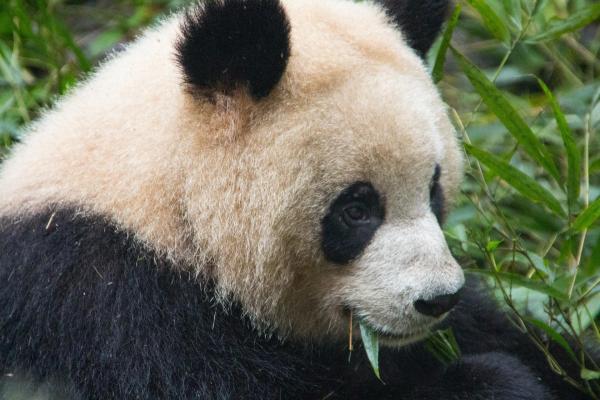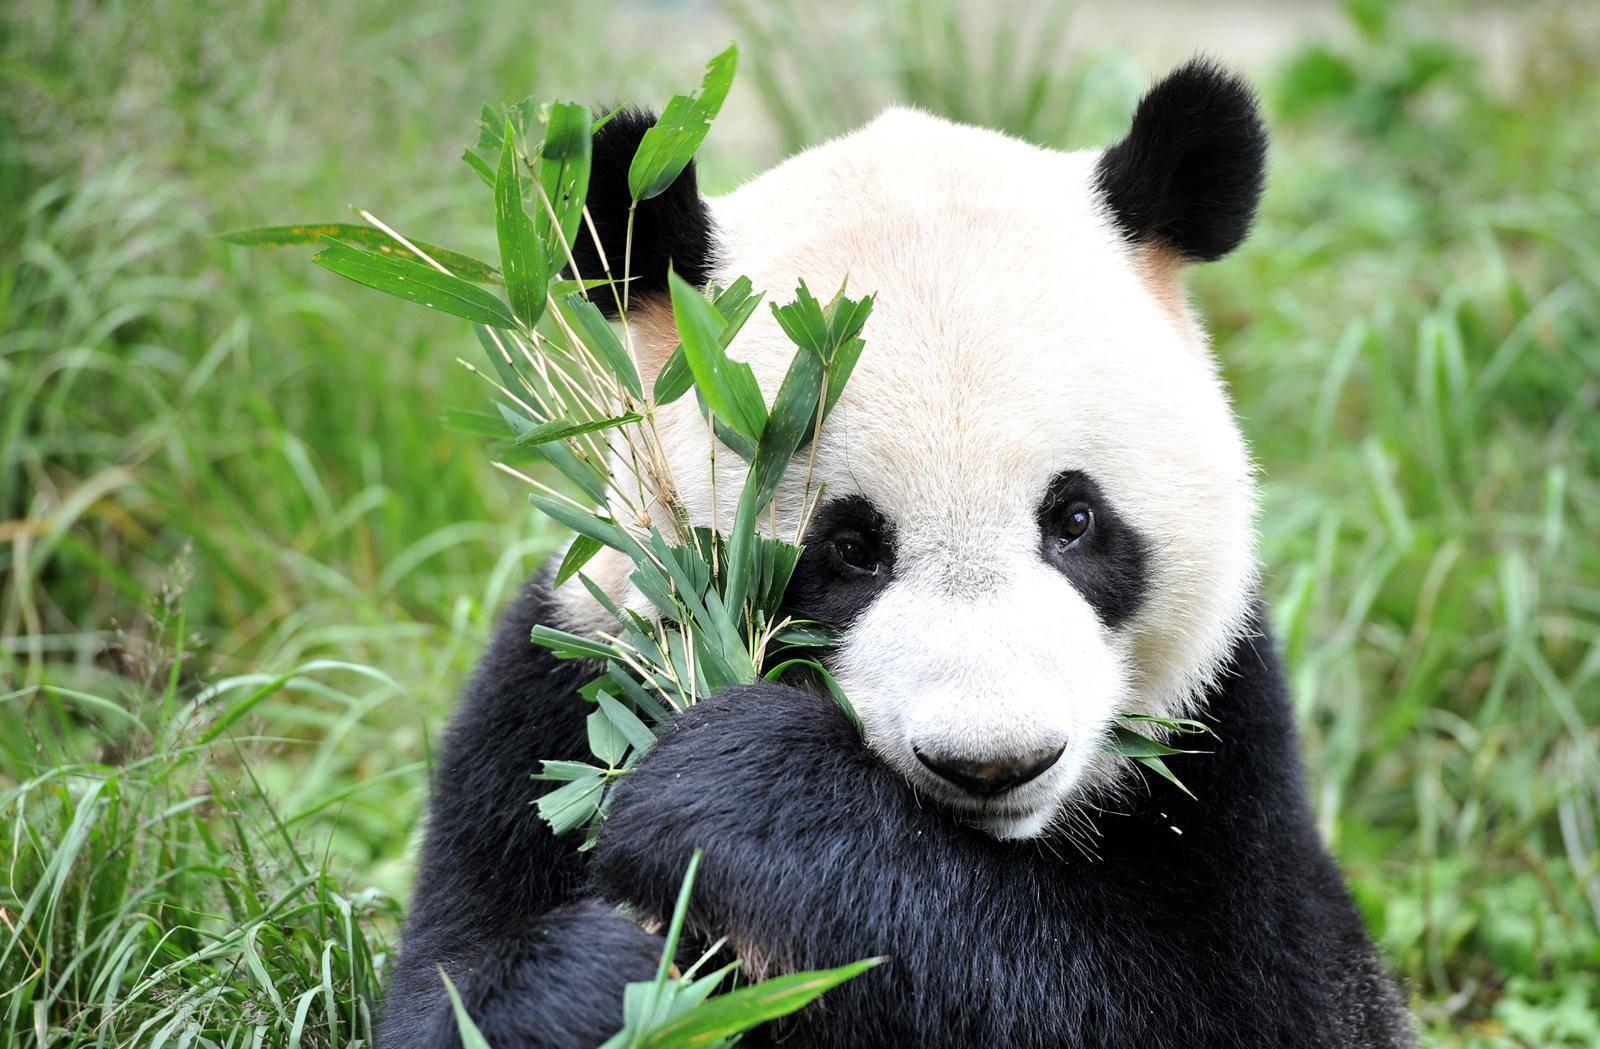The first image is the image on the left, the second image is the image on the right. Examine the images to the left and right. Is the description "All pandas are grasping part of a bamboo plant, and at least one of the pandas depicted faces forward with his rightward elbow bent and paw raised to his mouth." accurate? Answer yes or no. Yes. The first image is the image on the left, the second image is the image on the right. Evaluate the accuracy of this statement regarding the images: "there is a panda sitting on the ground in front of a fallen tree log with a standing tree trunk to the right of the panda". Is it true? Answer yes or no. No. 